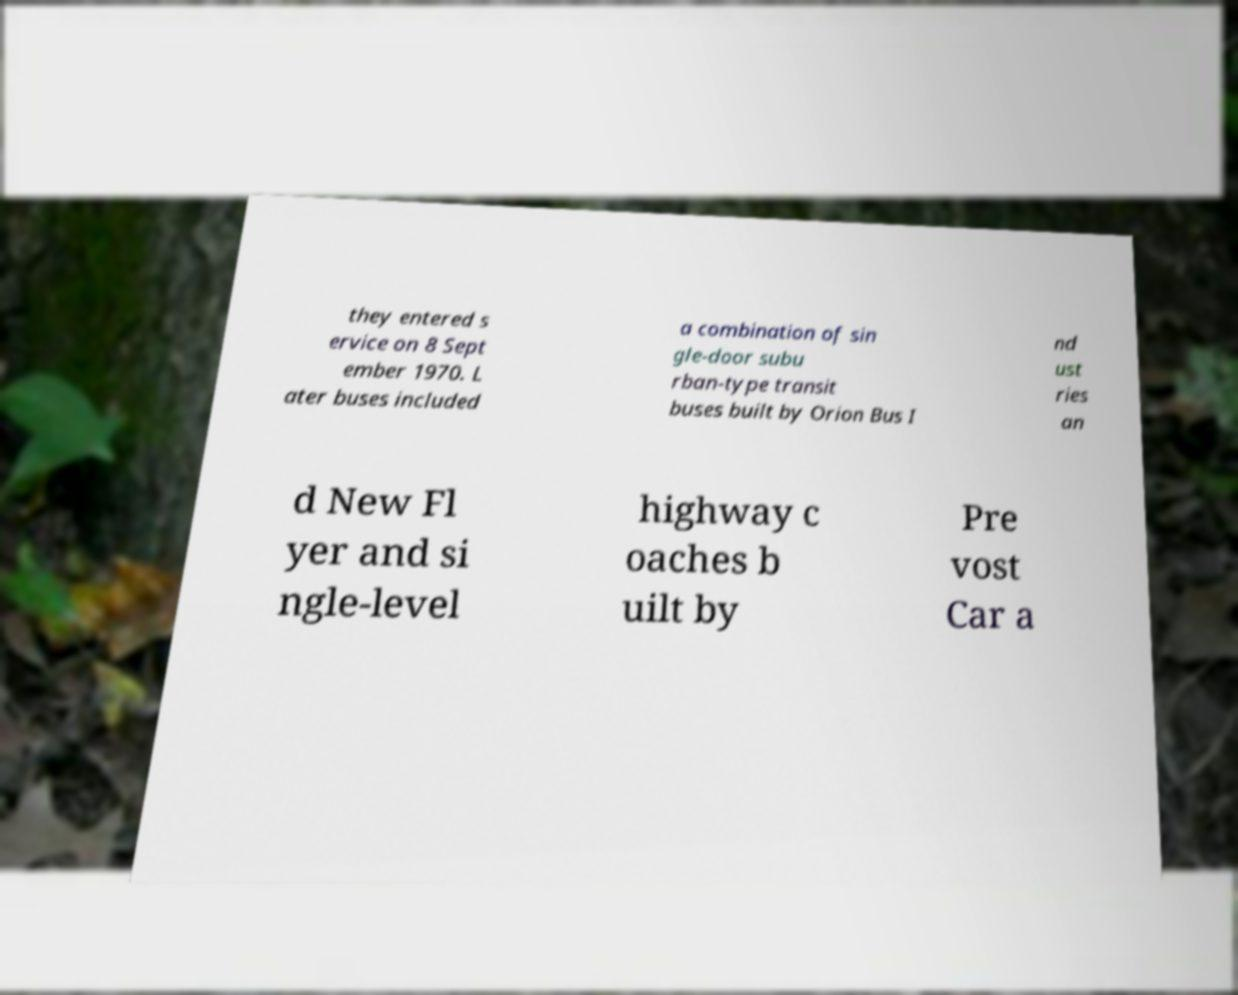Can you read and provide the text displayed in the image?This photo seems to have some interesting text. Can you extract and type it out for me? they entered s ervice on 8 Sept ember 1970. L ater buses included a combination of sin gle-door subu rban-type transit buses built by Orion Bus I nd ust ries an d New Fl yer and si ngle-level highway c oaches b uilt by Pre vost Car a 